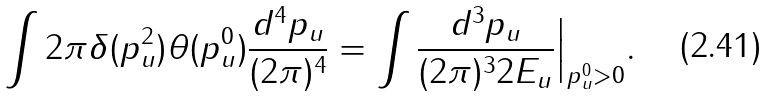<formula> <loc_0><loc_0><loc_500><loc_500>\int 2 \pi \delta ( p _ { u } ^ { 2 } ) \theta ( p _ { u } ^ { 0 } ) \frac { d ^ { 4 } p _ { u } } { ( 2 \pi ) ^ { 4 } } = \int \frac { d ^ { 3 } p _ { u } } { ( 2 \pi ) ^ { 3 } 2 E _ { u } } \Big | _ { p _ { u } ^ { 0 } > 0 } .</formula> 